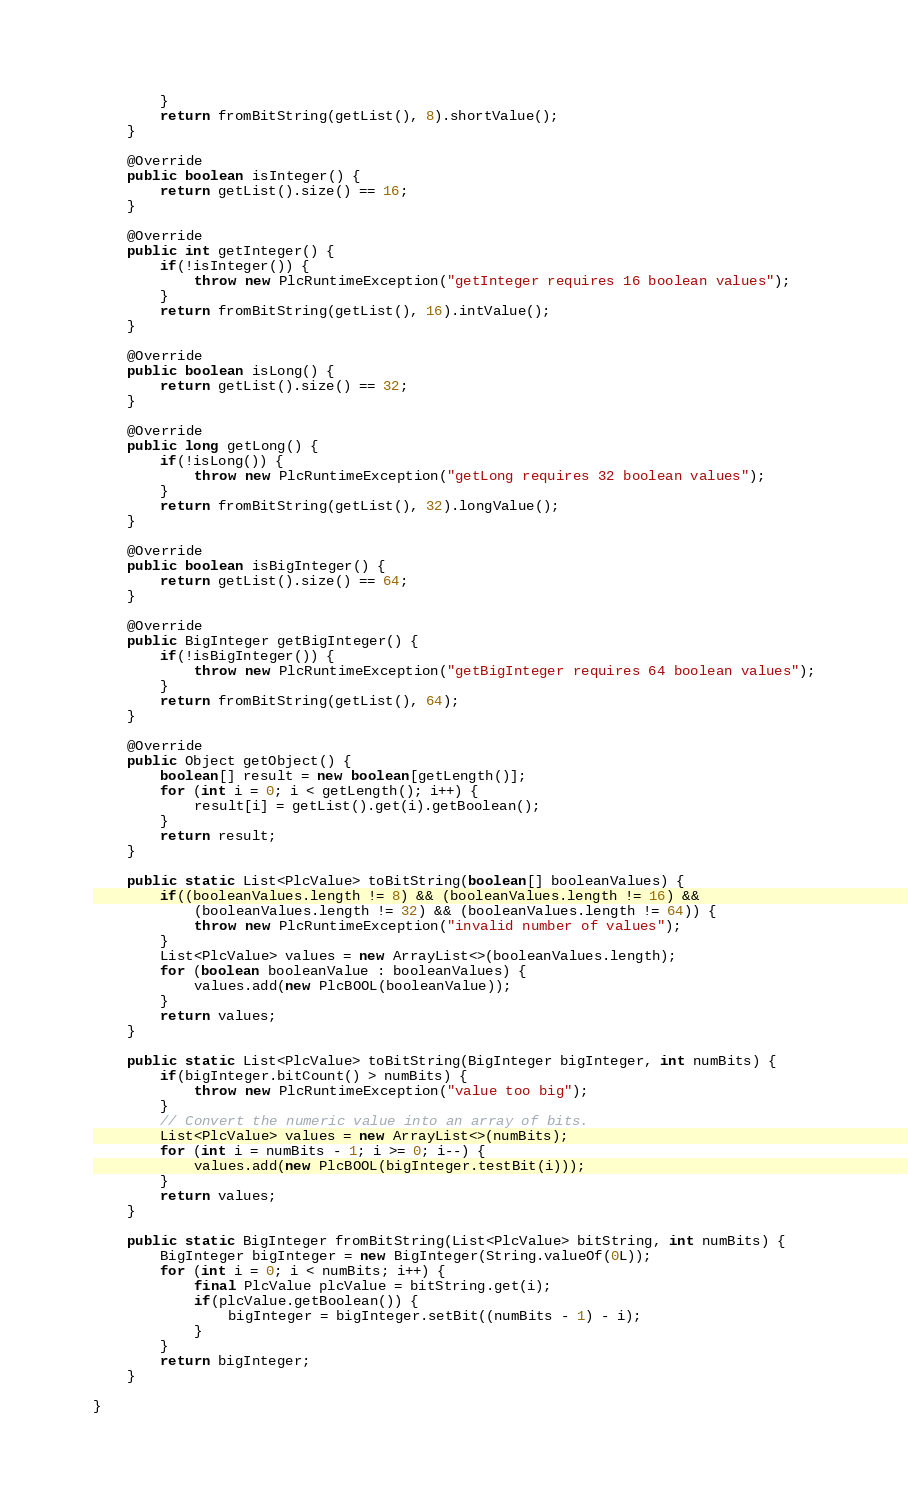Convert code to text. <code><loc_0><loc_0><loc_500><loc_500><_Java_>        }
        return fromBitString(getList(), 8).shortValue();
    }

    @Override
    public boolean isInteger() {
        return getList().size() == 16;
    }

    @Override
    public int getInteger() {
        if(!isInteger()) {
            throw new PlcRuntimeException("getInteger requires 16 boolean values");
        }
        return fromBitString(getList(), 16).intValue();
    }

    @Override
    public boolean isLong() {
        return getList().size() == 32;
    }

    @Override
    public long getLong() {
        if(!isLong()) {
            throw new PlcRuntimeException("getLong requires 32 boolean values");
        }
        return fromBitString(getList(), 32).longValue();
    }

    @Override
    public boolean isBigInteger() {
        return getList().size() == 64;
    }

    @Override
    public BigInteger getBigInteger() {
        if(!isBigInteger()) {
            throw new PlcRuntimeException("getBigInteger requires 64 boolean values");
        }
        return fromBitString(getList(), 64);
    }

    @Override
    public Object getObject() {
        boolean[] result = new boolean[getLength()];
        for (int i = 0; i < getLength(); i++) {
            result[i] = getList().get(i).getBoolean();
        }
        return result;
    }

    public static List<PlcValue> toBitString(boolean[] booleanValues) {
        if((booleanValues.length != 8) && (booleanValues.length != 16) &&
            (booleanValues.length != 32) && (booleanValues.length != 64)) {
            throw new PlcRuntimeException("invalid number of values");
        }
        List<PlcValue> values = new ArrayList<>(booleanValues.length);
        for (boolean booleanValue : booleanValues) {
            values.add(new PlcBOOL(booleanValue));
        }
        return values;
    }

    public static List<PlcValue> toBitString(BigInteger bigInteger, int numBits) {
        if(bigInteger.bitCount() > numBits) {
            throw new PlcRuntimeException("value too big");
        }
        // Convert the numeric value into an array of bits.
        List<PlcValue> values = new ArrayList<>(numBits);
        for (int i = numBits - 1; i >= 0; i--) {
            values.add(new PlcBOOL(bigInteger.testBit(i)));
        }
        return values;
    }

    public static BigInteger fromBitString(List<PlcValue> bitString, int numBits) {
        BigInteger bigInteger = new BigInteger(String.valueOf(0L));
        for (int i = 0; i < numBits; i++) {
            final PlcValue plcValue = bitString.get(i);
            if(plcValue.getBoolean()) {
                bigInteger = bigInteger.setBit((numBits - 1) - i);
            }
        }
        return bigInteger;
    }

}
</code> 